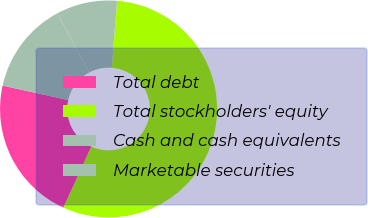Convert chart to OTSL. <chart><loc_0><loc_0><loc_500><loc_500><pie_chart><fcel>Total debt<fcel>Total stockholders' equity<fcel>Cash and cash equivalents<fcel>Marketable securities<nl><fcel>21.64%<fcel>55.58%<fcel>9.07%<fcel>13.72%<nl></chart> 